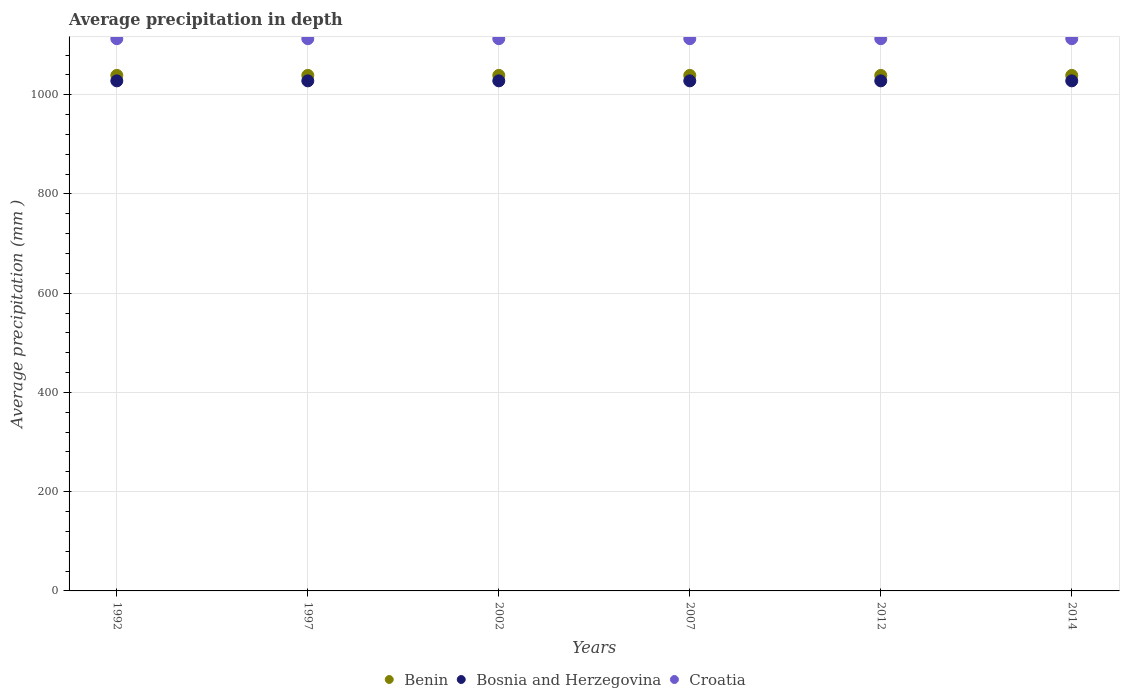How many different coloured dotlines are there?
Offer a terse response. 3. Is the number of dotlines equal to the number of legend labels?
Provide a short and direct response. Yes. What is the average precipitation in Bosnia and Herzegovina in 2007?
Provide a short and direct response. 1028. Across all years, what is the maximum average precipitation in Benin?
Your answer should be very brief. 1039. Across all years, what is the minimum average precipitation in Bosnia and Herzegovina?
Provide a succinct answer. 1028. In which year was the average precipitation in Croatia maximum?
Ensure brevity in your answer.  1992. What is the total average precipitation in Benin in the graph?
Offer a terse response. 6234. What is the difference between the average precipitation in Bosnia and Herzegovina in 1997 and that in 2012?
Provide a short and direct response. 0. What is the difference between the average precipitation in Bosnia and Herzegovina in 1992 and the average precipitation in Croatia in 1997?
Your answer should be compact. -85. What is the average average precipitation in Croatia per year?
Offer a very short reply. 1113. In the year 2012, what is the difference between the average precipitation in Croatia and average precipitation in Bosnia and Herzegovina?
Your response must be concise. 85. In how many years, is the average precipitation in Benin greater than 880 mm?
Your answer should be very brief. 6. What is the ratio of the average precipitation in Croatia in 1997 to that in 2007?
Ensure brevity in your answer.  1. Is the average precipitation in Bosnia and Herzegovina in 1992 less than that in 2002?
Keep it short and to the point. No. What is the difference between the highest and the second highest average precipitation in Croatia?
Provide a short and direct response. 0. In how many years, is the average precipitation in Bosnia and Herzegovina greater than the average average precipitation in Bosnia and Herzegovina taken over all years?
Offer a terse response. 0. Is the average precipitation in Croatia strictly greater than the average precipitation in Bosnia and Herzegovina over the years?
Ensure brevity in your answer.  Yes. How many years are there in the graph?
Provide a succinct answer. 6. Does the graph contain grids?
Your response must be concise. Yes. Where does the legend appear in the graph?
Keep it short and to the point. Bottom center. How are the legend labels stacked?
Provide a succinct answer. Horizontal. What is the title of the graph?
Your answer should be compact. Average precipitation in depth. What is the label or title of the Y-axis?
Ensure brevity in your answer.  Average precipitation (mm ). What is the Average precipitation (mm ) of Benin in 1992?
Offer a very short reply. 1039. What is the Average precipitation (mm ) of Bosnia and Herzegovina in 1992?
Make the answer very short. 1028. What is the Average precipitation (mm ) in Croatia in 1992?
Keep it short and to the point. 1113. What is the Average precipitation (mm ) in Benin in 1997?
Offer a terse response. 1039. What is the Average precipitation (mm ) in Bosnia and Herzegovina in 1997?
Provide a short and direct response. 1028. What is the Average precipitation (mm ) of Croatia in 1997?
Provide a short and direct response. 1113. What is the Average precipitation (mm ) of Benin in 2002?
Provide a short and direct response. 1039. What is the Average precipitation (mm ) in Bosnia and Herzegovina in 2002?
Your answer should be compact. 1028. What is the Average precipitation (mm ) of Croatia in 2002?
Offer a terse response. 1113. What is the Average precipitation (mm ) of Benin in 2007?
Offer a terse response. 1039. What is the Average precipitation (mm ) of Bosnia and Herzegovina in 2007?
Offer a very short reply. 1028. What is the Average precipitation (mm ) of Croatia in 2007?
Your answer should be compact. 1113. What is the Average precipitation (mm ) of Benin in 2012?
Make the answer very short. 1039. What is the Average precipitation (mm ) in Bosnia and Herzegovina in 2012?
Your answer should be very brief. 1028. What is the Average precipitation (mm ) of Croatia in 2012?
Keep it short and to the point. 1113. What is the Average precipitation (mm ) in Benin in 2014?
Your answer should be very brief. 1039. What is the Average precipitation (mm ) in Bosnia and Herzegovina in 2014?
Your answer should be very brief. 1028. What is the Average precipitation (mm ) of Croatia in 2014?
Offer a terse response. 1113. Across all years, what is the maximum Average precipitation (mm ) of Benin?
Offer a terse response. 1039. Across all years, what is the maximum Average precipitation (mm ) in Bosnia and Herzegovina?
Your response must be concise. 1028. Across all years, what is the maximum Average precipitation (mm ) in Croatia?
Provide a short and direct response. 1113. Across all years, what is the minimum Average precipitation (mm ) of Benin?
Keep it short and to the point. 1039. Across all years, what is the minimum Average precipitation (mm ) in Bosnia and Herzegovina?
Your answer should be compact. 1028. Across all years, what is the minimum Average precipitation (mm ) in Croatia?
Offer a very short reply. 1113. What is the total Average precipitation (mm ) of Benin in the graph?
Make the answer very short. 6234. What is the total Average precipitation (mm ) of Bosnia and Herzegovina in the graph?
Your answer should be very brief. 6168. What is the total Average precipitation (mm ) in Croatia in the graph?
Ensure brevity in your answer.  6678. What is the difference between the Average precipitation (mm ) in Croatia in 1992 and that in 1997?
Your answer should be compact. 0. What is the difference between the Average precipitation (mm ) of Bosnia and Herzegovina in 1992 and that in 2002?
Offer a very short reply. 0. What is the difference between the Average precipitation (mm ) in Croatia in 1992 and that in 2002?
Your response must be concise. 0. What is the difference between the Average precipitation (mm ) of Bosnia and Herzegovina in 1992 and that in 2007?
Ensure brevity in your answer.  0. What is the difference between the Average precipitation (mm ) of Croatia in 1992 and that in 2007?
Ensure brevity in your answer.  0. What is the difference between the Average precipitation (mm ) of Benin in 1992 and that in 2012?
Your answer should be compact. 0. What is the difference between the Average precipitation (mm ) of Bosnia and Herzegovina in 1992 and that in 2012?
Your answer should be very brief. 0. What is the difference between the Average precipitation (mm ) of Croatia in 1992 and that in 2012?
Offer a very short reply. 0. What is the difference between the Average precipitation (mm ) of Benin in 1992 and that in 2014?
Offer a very short reply. 0. What is the difference between the Average precipitation (mm ) in Bosnia and Herzegovina in 1992 and that in 2014?
Offer a terse response. 0. What is the difference between the Average precipitation (mm ) of Croatia in 1992 and that in 2014?
Offer a terse response. 0. What is the difference between the Average precipitation (mm ) of Bosnia and Herzegovina in 1997 and that in 2002?
Make the answer very short. 0. What is the difference between the Average precipitation (mm ) of Croatia in 1997 and that in 2002?
Give a very brief answer. 0. What is the difference between the Average precipitation (mm ) of Bosnia and Herzegovina in 1997 and that in 2007?
Offer a very short reply. 0. What is the difference between the Average precipitation (mm ) of Croatia in 1997 and that in 2007?
Provide a succinct answer. 0. What is the difference between the Average precipitation (mm ) in Croatia in 1997 and that in 2012?
Offer a very short reply. 0. What is the difference between the Average precipitation (mm ) of Croatia in 1997 and that in 2014?
Your response must be concise. 0. What is the difference between the Average precipitation (mm ) in Benin in 2002 and that in 2007?
Provide a short and direct response. 0. What is the difference between the Average precipitation (mm ) in Bosnia and Herzegovina in 2002 and that in 2007?
Keep it short and to the point. 0. What is the difference between the Average precipitation (mm ) in Croatia in 2002 and that in 2012?
Your response must be concise. 0. What is the difference between the Average precipitation (mm ) of Benin in 2002 and that in 2014?
Your answer should be very brief. 0. What is the difference between the Average precipitation (mm ) in Croatia in 2002 and that in 2014?
Your answer should be very brief. 0. What is the difference between the Average precipitation (mm ) in Bosnia and Herzegovina in 2007 and that in 2012?
Give a very brief answer. 0. What is the difference between the Average precipitation (mm ) of Benin in 2007 and that in 2014?
Keep it short and to the point. 0. What is the difference between the Average precipitation (mm ) in Benin in 1992 and the Average precipitation (mm ) in Croatia in 1997?
Provide a succinct answer. -74. What is the difference between the Average precipitation (mm ) in Bosnia and Herzegovina in 1992 and the Average precipitation (mm ) in Croatia in 1997?
Give a very brief answer. -85. What is the difference between the Average precipitation (mm ) of Benin in 1992 and the Average precipitation (mm ) of Croatia in 2002?
Give a very brief answer. -74. What is the difference between the Average precipitation (mm ) in Bosnia and Herzegovina in 1992 and the Average precipitation (mm ) in Croatia in 2002?
Offer a very short reply. -85. What is the difference between the Average precipitation (mm ) of Benin in 1992 and the Average precipitation (mm ) of Croatia in 2007?
Ensure brevity in your answer.  -74. What is the difference between the Average precipitation (mm ) of Bosnia and Herzegovina in 1992 and the Average precipitation (mm ) of Croatia in 2007?
Your answer should be very brief. -85. What is the difference between the Average precipitation (mm ) in Benin in 1992 and the Average precipitation (mm ) in Bosnia and Herzegovina in 2012?
Provide a succinct answer. 11. What is the difference between the Average precipitation (mm ) of Benin in 1992 and the Average precipitation (mm ) of Croatia in 2012?
Offer a very short reply. -74. What is the difference between the Average precipitation (mm ) of Bosnia and Herzegovina in 1992 and the Average precipitation (mm ) of Croatia in 2012?
Offer a very short reply. -85. What is the difference between the Average precipitation (mm ) in Benin in 1992 and the Average precipitation (mm ) in Bosnia and Herzegovina in 2014?
Offer a very short reply. 11. What is the difference between the Average precipitation (mm ) in Benin in 1992 and the Average precipitation (mm ) in Croatia in 2014?
Give a very brief answer. -74. What is the difference between the Average precipitation (mm ) in Bosnia and Herzegovina in 1992 and the Average precipitation (mm ) in Croatia in 2014?
Offer a very short reply. -85. What is the difference between the Average precipitation (mm ) of Benin in 1997 and the Average precipitation (mm ) of Bosnia and Herzegovina in 2002?
Ensure brevity in your answer.  11. What is the difference between the Average precipitation (mm ) of Benin in 1997 and the Average precipitation (mm ) of Croatia in 2002?
Offer a very short reply. -74. What is the difference between the Average precipitation (mm ) of Bosnia and Herzegovina in 1997 and the Average precipitation (mm ) of Croatia in 2002?
Offer a very short reply. -85. What is the difference between the Average precipitation (mm ) of Benin in 1997 and the Average precipitation (mm ) of Croatia in 2007?
Make the answer very short. -74. What is the difference between the Average precipitation (mm ) of Bosnia and Herzegovina in 1997 and the Average precipitation (mm ) of Croatia in 2007?
Keep it short and to the point. -85. What is the difference between the Average precipitation (mm ) of Benin in 1997 and the Average precipitation (mm ) of Croatia in 2012?
Offer a very short reply. -74. What is the difference between the Average precipitation (mm ) in Bosnia and Herzegovina in 1997 and the Average precipitation (mm ) in Croatia in 2012?
Make the answer very short. -85. What is the difference between the Average precipitation (mm ) of Benin in 1997 and the Average precipitation (mm ) of Bosnia and Herzegovina in 2014?
Ensure brevity in your answer.  11. What is the difference between the Average precipitation (mm ) in Benin in 1997 and the Average precipitation (mm ) in Croatia in 2014?
Ensure brevity in your answer.  -74. What is the difference between the Average precipitation (mm ) in Bosnia and Herzegovina in 1997 and the Average precipitation (mm ) in Croatia in 2014?
Your answer should be very brief. -85. What is the difference between the Average precipitation (mm ) in Benin in 2002 and the Average precipitation (mm ) in Croatia in 2007?
Your answer should be compact. -74. What is the difference between the Average precipitation (mm ) of Bosnia and Herzegovina in 2002 and the Average precipitation (mm ) of Croatia in 2007?
Ensure brevity in your answer.  -85. What is the difference between the Average precipitation (mm ) in Benin in 2002 and the Average precipitation (mm ) in Croatia in 2012?
Give a very brief answer. -74. What is the difference between the Average precipitation (mm ) in Bosnia and Herzegovina in 2002 and the Average precipitation (mm ) in Croatia in 2012?
Offer a terse response. -85. What is the difference between the Average precipitation (mm ) of Benin in 2002 and the Average precipitation (mm ) of Croatia in 2014?
Keep it short and to the point. -74. What is the difference between the Average precipitation (mm ) of Bosnia and Herzegovina in 2002 and the Average precipitation (mm ) of Croatia in 2014?
Offer a very short reply. -85. What is the difference between the Average precipitation (mm ) of Benin in 2007 and the Average precipitation (mm ) of Bosnia and Herzegovina in 2012?
Your answer should be compact. 11. What is the difference between the Average precipitation (mm ) in Benin in 2007 and the Average precipitation (mm ) in Croatia in 2012?
Keep it short and to the point. -74. What is the difference between the Average precipitation (mm ) in Bosnia and Herzegovina in 2007 and the Average precipitation (mm ) in Croatia in 2012?
Your answer should be very brief. -85. What is the difference between the Average precipitation (mm ) in Benin in 2007 and the Average precipitation (mm ) in Croatia in 2014?
Your answer should be compact. -74. What is the difference between the Average precipitation (mm ) in Bosnia and Herzegovina in 2007 and the Average precipitation (mm ) in Croatia in 2014?
Give a very brief answer. -85. What is the difference between the Average precipitation (mm ) of Benin in 2012 and the Average precipitation (mm ) of Croatia in 2014?
Give a very brief answer. -74. What is the difference between the Average precipitation (mm ) of Bosnia and Herzegovina in 2012 and the Average precipitation (mm ) of Croatia in 2014?
Provide a short and direct response. -85. What is the average Average precipitation (mm ) in Benin per year?
Ensure brevity in your answer.  1039. What is the average Average precipitation (mm ) in Bosnia and Herzegovina per year?
Offer a terse response. 1028. What is the average Average precipitation (mm ) of Croatia per year?
Your answer should be compact. 1113. In the year 1992, what is the difference between the Average precipitation (mm ) of Benin and Average precipitation (mm ) of Bosnia and Herzegovina?
Keep it short and to the point. 11. In the year 1992, what is the difference between the Average precipitation (mm ) in Benin and Average precipitation (mm ) in Croatia?
Offer a terse response. -74. In the year 1992, what is the difference between the Average precipitation (mm ) of Bosnia and Herzegovina and Average precipitation (mm ) of Croatia?
Provide a succinct answer. -85. In the year 1997, what is the difference between the Average precipitation (mm ) of Benin and Average precipitation (mm ) of Croatia?
Your answer should be very brief. -74. In the year 1997, what is the difference between the Average precipitation (mm ) in Bosnia and Herzegovina and Average precipitation (mm ) in Croatia?
Your answer should be compact. -85. In the year 2002, what is the difference between the Average precipitation (mm ) of Benin and Average precipitation (mm ) of Croatia?
Provide a succinct answer. -74. In the year 2002, what is the difference between the Average precipitation (mm ) in Bosnia and Herzegovina and Average precipitation (mm ) in Croatia?
Your answer should be very brief. -85. In the year 2007, what is the difference between the Average precipitation (mm ) in Benin and Average precipitation (mm ) in Bosnia and Herzegovina?
Your response must be concise. 11. In the year 2007, what is the difference between the Average precipitation (mm ) in Benin and Average precipitation (mm ) in Croatia?
Keep it short and to the point. -74. In the year 2007, what is the difference between the Average precipitation (mm ) in Bosnia and Herzegovina and Average precipitation (mm ) in Croatia?
Make the answer very short. -85. In the year 2012, what is the difference between the Average precipitation (mm ) in Benin and Average precipitation (mm ) in Bosnia and Herzegovina?
Give a very brief answer. 11. In the year 2012, what is the difference between the Average precipitation (mm ) of Benin and Average precipitation (mm ) of Croatia?
Your response must be concise. -74. In the year 2012, what is the difference between the Average precipitation (mm ) in Bosnia and Herzegovina and Average precipitation (mm ) in Croatia?
Offer a very short reply. -85. In the year 2014, what is the difference between the Average precipitation (mm ) in Benin and Average precipitation (mm ) in Bosnia and Herzegovina?
Keep it short and to the point. 11. In the year 2014, what is the difference between the Average precipitation (mm ) of Benin and Average precipitation (mm ) of Croatia?
Make the answer very short. -74. In the year 2014, what is the difference between the Average precipitation (mm ) of Bosnia and Herzegovina and Average precipitation (mm ) of Croatia?
Provide a succinct answer. -85. What is the ratio of the Average precipitation (mm ) of Benin in 1992 to that in 1997?
Your answer should be compact. 1. What is the ratio of the Average precipitation (mm ) of Bosnia and Herzegovina in 1992 to that in 1997?
Ensure brevity in your answer.  1. What is the ratio of the Average precipitation (mm ) in Benin in 1992 to that in 2002?
Make the answer very short. 1. What is the ratio of the Average precipitation (mm ) of Croatia in 1992 to that in 2002?
Provide a short and direct response. 1. What is the ratio of the Average precipitation (mm ) of Benin in 1992 to that in 2007?
Make the answer very short. 1. What is the ratio of the Average precipitation (mm ) in Bosnia and Herzegovina in 1992 to that in 2007?
Your response must be concise. 1. What is the ratio of the Average precipitation (mm ) in Croatia in 1992 to that in 2007?
Offer a very short reply. 1. What is the ratio of the Average precipitation (mm ) in Bosnia and Herzegovina in 1992 to that in 2012?
Give a very brief answer. 1. What is the ratio of the Average precipitation (mm ) of Benin in 1992 to that in 2014?
Give a very brief answer. 1. What is the ratio of the Average precipitation (mm ) of Benin in 1997 to that in 2002?
Your response must be concise. 1. What is the ratio of the Average precipitation (mm ) of Croatia in 1997 to that in 2002?
Make the answer very short. 1. What is the ratio of the Average precipitation (mm ) of Croatia in 1997 to that in 2012?
Provide a succinct answer. 1. What is the ratio of the Average precipitation (mm ) in Bosnia and Herzegovina in 1997 to that in 2014?
Give a very brief answer. 1. What is the ratio of the Average precipitation (mm ) of Croatia in 1997 to that in 2014?
Make the answer very short. 1. What is the ratio of the Average precipitation (mm ) in Benin in 2002 to that in 2007?
Offer a terse response. 1. What is the ratio of the Average precipitation (mm ) of Bosnia and Herzegovina in 2002 to that in 2007?
Your answer should be compact. 1. What is the ratio of the Average precipitation (mm ) in Croatia in 2002 to that in 2007?
Give a very brief answer. 1. What is the ratio of the Average precipitation (mm ) in Benin in 2002 to that in 2012?
Provide a short and direct response. 1. What is the ratio of the Average precipitation (mm ) in Benin in 2002 to that in 2014?
Your answer should be compact. 1. What is the ratio of the Average precipitation (mm ) of Bosnia and Herzegovina in 2002 to that in 2014?
Offer a terse response. 1. What is the ratio of the Average precipitation (mm ) of Croatia in 2002 to that in 2014?
Your response must be concise. 1. What is the ratio of the Average precipitation (mm ) in Benin in 2007 to that in 2012?
Your response must be concise. 1. What is the ratio of the Average precipitation (mm ) of Bosnia and Herzegovina in 2007 to that in 2012?
Make the answer very short. 1. What is the ratio of the Average precipitation (mm ) in Bosnia and Herzegovina in 2007 to that in 2014?
Provide a short and direct response. 1. What is the ratio of the Average precipitation (mm ) in Bosnia and Herzegovina in 2012 to that in 2014?
Provide a succinct answer. 1. What is the difference between the highest and the second highest Average precipitation (mm ) of Benin?
Your answer should be very brief. 0. What is the difference between the highest and the second highest Average precipitation (mm ) of Bosnia and Herzegovina?
Your answer should be compact. 0. What is the difference between the highest and the lowest Average precipitation (mm ) of Bosnia and Herzegovina?
Your response must be concise. 0. 